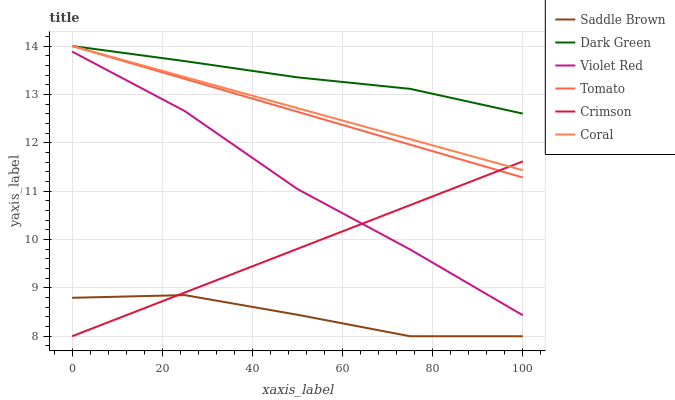Does Saddle Brown have the minimum area under the curve?
Answer yes or no. Yes. Does Dark Green have the maximum area under the curve?
Answer yes or no. Yes. Does Violet Red have the minimum area under the curve?
Answer yes or no. No. Does Violet Red have the maximum area under the curve?
Answer yes or no. No. Is Tomato the smoothest?
Answer yes or no. Yes. Is Saddle Brown the roughest?
Answer yes or no. Yes. Is Violet Red the smoothest?
Answer yes or no. No. Is Violet Red the roughest?
Answer yes or no. No. Does Crimson have the lowest value?
Answer yes or no. Yes. Does Violet Red have the lowest value?
Answer yes or no. No. Does Dark Green have the highest value?
Answer yes or no. Yes. Does Violet Red have the highest value?
Answer yes or no. No. Is Violet Red less than Tomato?
Answer yes or no. Yes. Is Coral greater than Saddle Brown?
Answer yes or no. Yes. Does Tomato intersect Crimson?
Answer yes or no. Yes. Is Tomato less than Crimson?
Answer yes or no. No. Is Tomato greater than Crimson?
Answer yes or no. No. Does Violet Red intersect Tomato?
Answer yes or no. No. 